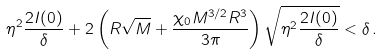<formula> <loc_0><loc_0><loc_500><loc_500>\eta ^ { 2 } \frac { 2 I ( 0 ) } { \delta } + 2 \left ( R \sqrt { M } + \frac { \chi _ { 0 } M ^ { 3 / 2 } R ^ { 3 } } { 3 \pi } \right ) \sqrt { \eta ^ { 2 } \frac { 2 I ( 0 ) } { \delta } } < \delta \, .</formula> 